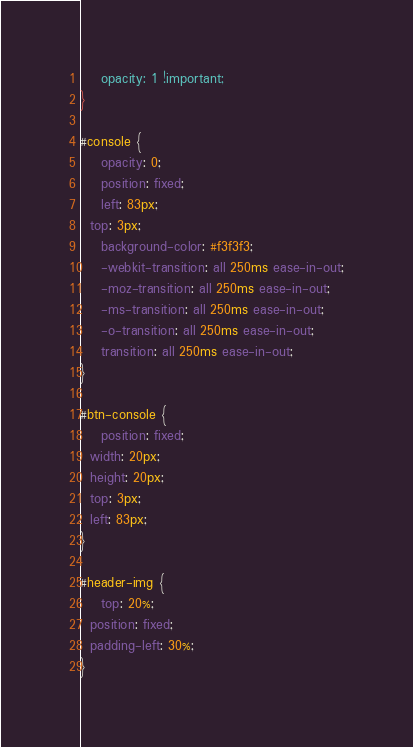<code> <loc_0><loc_0><loc_500><loc_500><_CSS_>	opacity: 1 !important;
}

#console {
	opacity: 0;
	position: fixed;
	left: 83px;
  top: 3px;
	background-color: #f3f3f3;
	-webkit-transition: all 250ms ease-in-out;
	-moz-transition: all 250ms ease-in-out;
	-ms-transition: all 250ms ease-in-out;
	-o-transition: all 250ms ease-in-out;
	transition: all 250ms ease-in-out;
}

#btn-console {
	position: fixed;
  width: 20px;
  height: 20px;
  top: 3px;
  left: 83px;
}

#header-img {
	top: 20%;
  position: fixed;
  padding-left: 30%;
}
</code> 